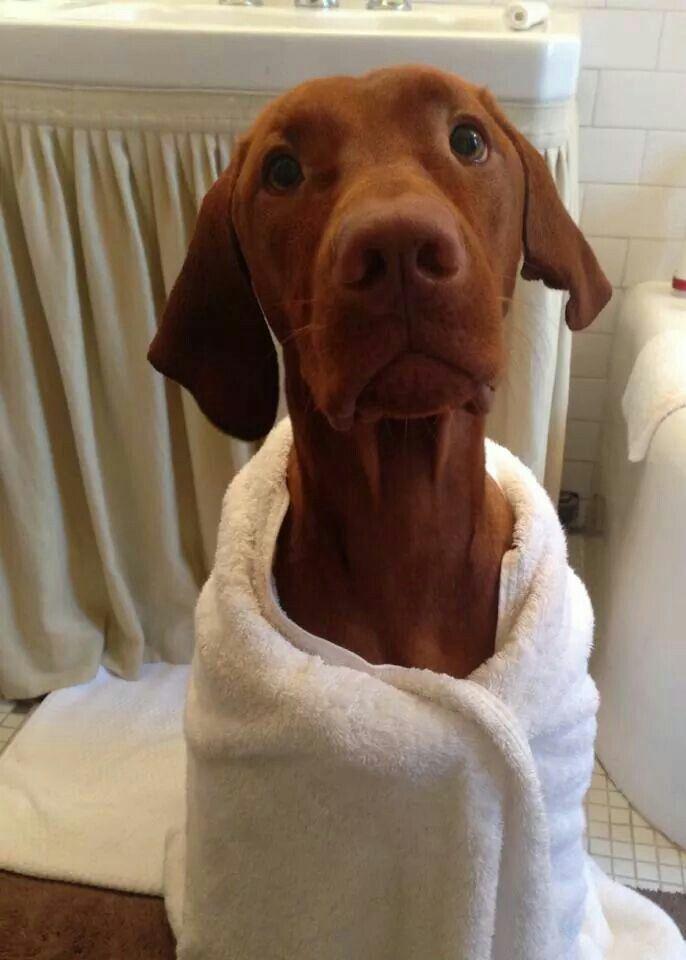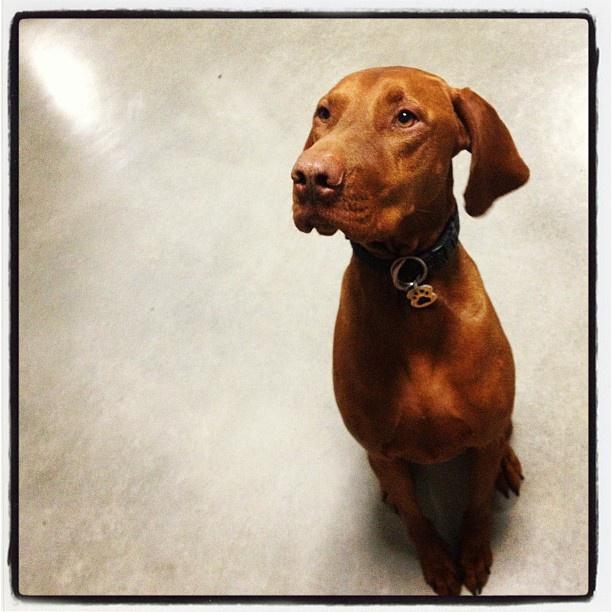The first image is the image on the left, the second image is the image on the right. Considering the images on both sides, is "Each image contains only one dog and it is sitting" valid? Answer yes or no. Yes. The first image is the image on the left, the second image is the image on the right. Considering the images on both sides, is "Each image includes a red-orange dog with floppy ears in an upright sitting position, the dog depicted in the left image is facing forward, and a dog depicted in the right image has something on top of its muzzle." valid? Answer yes or no. No. 